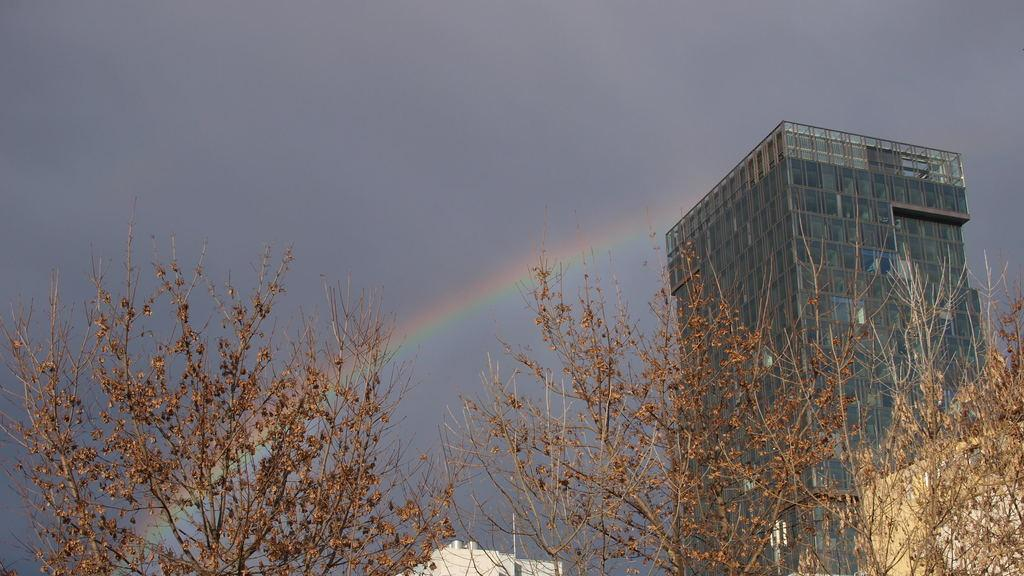What type of plants are in the foreground of the image? There are dry plants in the foreground of the image. What can be seen behind the plants? There is a building visible behind the plants. What is present in the sky in the image? There is a rainbow in the sky in the image}. What type of vegetable is growing next to the dry plants in the image? There is no vegetable present in the image; it only features dry plants and a building in the background. Can you describe the haircut of the person standing next to the building in the image? There is no person present in the image, so it is not possible to describe their haircut. 